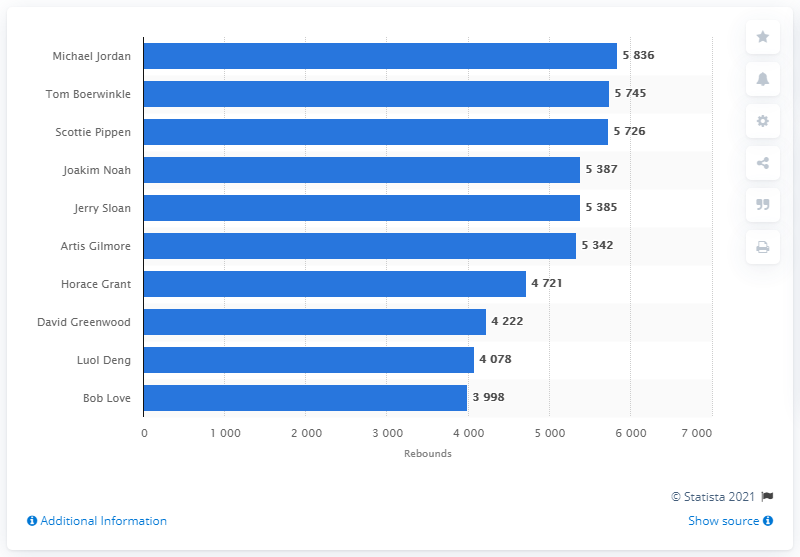Point out several critical features in this image. The career rebound leader of the Chicago Bulls is Michael Jordan. 